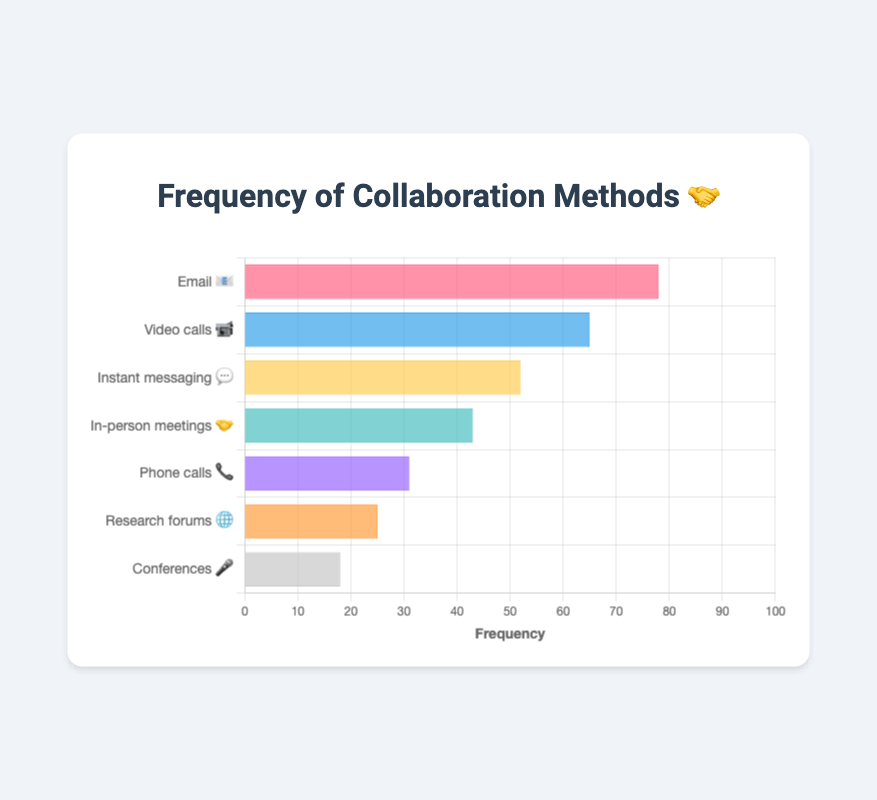What is the title of the chart? The title of the chart is usually positioned at the top and provides a summary of what the chart is about. In this case, it is "Frequency of Collaboration Methods 🤝".
Answer: Frequency of Collaboration Methods 🤝 Which communication method has the highest frequency of collaboration? The bar with the highest value represents the communication method with the highest frequency. "Email 📧" has the highest frequency of 78.
Answer: Email 📧 How many communication methods are displayed in the chart? To determine the number of communication methods, count the number of bars or labels on the y-axis. There are 7 communication methods in the chart.
Answer: 7 What's the average frequency of all the communication methods? To find the average, sum the frequencies (78 + 65 + 52 + 43 + 31 + 25 + 18 = 312) and divide by the number of methods (7). So, 312 / 7.
Answer: 44.57 Which communication method is the least frequent for collaboration? The bar with the lowest value represents the least frequent method. "Conferences 🎤" has the frequency of 18.
Answer: Conferences 🎤 How does the frequency of "Video calls 📹" compare to "In-person meetings 🤝"? Compare the two frequencies directly. "Video calls 📹" have a frequency of 65, and "In-person meetings 🤝" have a frequency of 43. So, 65 is greater than 43.
Answer: Video calls 📹 > In-person meetings 🤝 What is the combined frequency of "Email 📧" and "Video calls 📹"? Sum the frequencies of both methods. For "Email 📧" it is 78, and for "Video calls 📹" it is 65. So, 78 + 65 = 143.
Answer: 143 Order the communication methods from most to least frequent. List all communication methods in descending order of their frequencies: "Email 📧" (78), "Video calls 📹" (65), "Instant messaging 💬" (52), "In-person meetings 🤝" (43), "Phone calls 📞" (31), "Research forums 🌐" (25), and "Conferences 🎤" (18).
Answer: Email 📧, Video calls 📹, Instant messaging 💬, In-person meetings 🤝, Phone calls 📞, Research forums 🌐, Conferences 🎤 